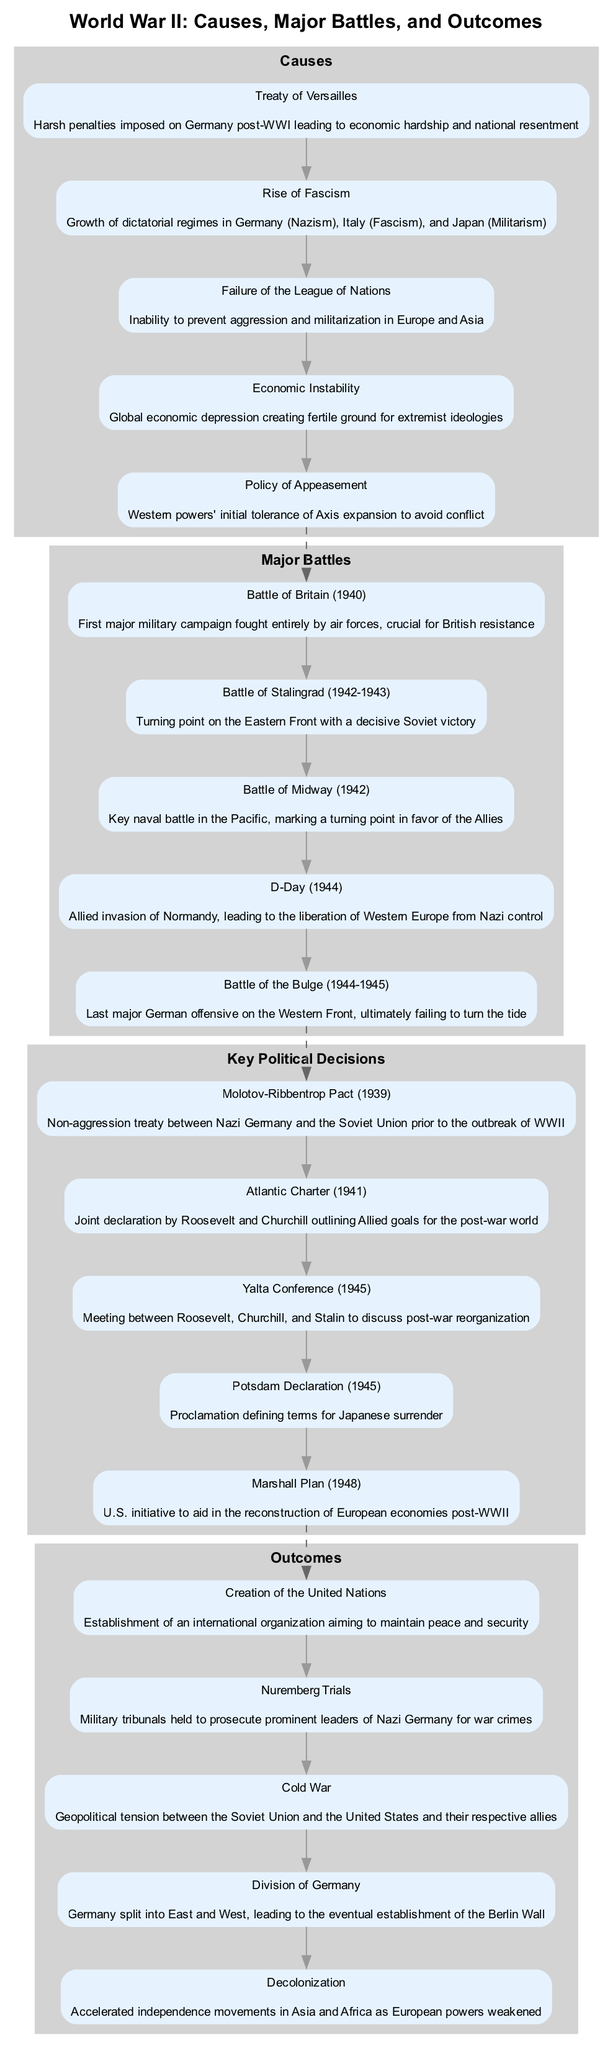What are the first three causes of World War II listed in the diagram? The diagram shows that the first three causes are: "Treaty of Versailles," "Rise of Fascism," and "Failure of the League of Nations." These elements sequentially appear as the first three nodes in the "Causes" section.
Answer: Treaty of Versailles, Rise of Fascism, Failure of the League of Nations Which battle is described as the turning point on the Eastern Front? According to the "Major Battles" section, the "Battle of Stalingrad" is labeled as the turning point on the Eastern Front, emphasizing its significance in the context of the war.
Answer: Battle of Stalingrad How many elements are listed under the "Outcomes" section? By counting the nodes in the "Outcomes" section of the diagram, there are a total of five elements listed: "Creation of the United Nations," "Nuremberg Trials," "Cold War," "Division of Germany," and "Decolonization."
Answer: 5 What connects the "Key Political Decisions" to the "Outcomes" section? The diagram features a dashed edge connecting the last element of "Key Political Decisions" ("Marshall Plan") to the first element of "Outcomes" ("Creation of the United Nations"). This indicates a relationship where the decisions impact the results in the following section.
Answer: Marshall Plan to Creation of the United Nations What was the policy initially followed by western powers to avoid conflict? The "Causes" section of the diagram identifies "Policy of Appeasement" as the specific policy adopted by western powers to tolerate Axis expansion in hopes of avoiding war.
Answer: Policy of Appeasement Which event is considered the Allied invasion of Normandy? The term "D-Day" in the "Major Battles" section describes the Allied invasion of Normandy, which is marked as a critical operation in the liberation of Western Europe.
Answer: D-Day What proclamation defined terms for Japanese surrender during WWII? The "Potsdam Declaration" in the "Key Political Decisions" section explicitly states that it is the proclamation defining the terms for Japanese surrender, thus highlighting its historical importance.
Answer: Potsdam Declaration What was the key naval battle that marked a turning point in the Pacific in favor of the Allies? The "Battle of Midway" is specified in the "Major Battles" section as the key naval battle that signified a turning point in favor of the Allies in the Pacific theater.
Answer: Battle of Midway 